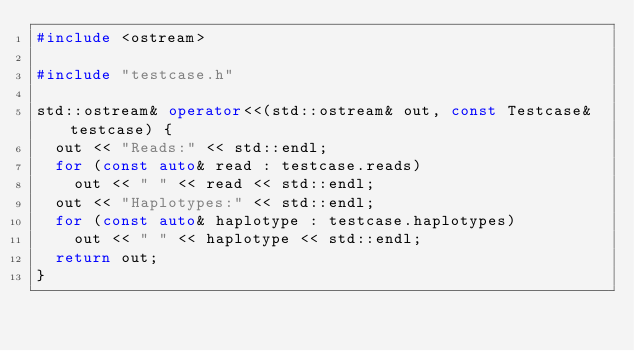Convert code to text. <code><loc_0><loc_0><loc_500><loc_500><_C++_>#include <ostream>

#include "testcase.h"

std::ostream& operator<<(std::ostream& out, const Testcase& testcase) {
  out << "Reads:" << std::endl;
  for (const auto& read : testcase.reads)
    out << " " << read << std::endl;
  out << "Haplotypes:" << std::endl;
  for (const auto& haplotype : testcase.haplotypes)
    out << " " << haplotype << std::endl;
  return out;
}
</code> 